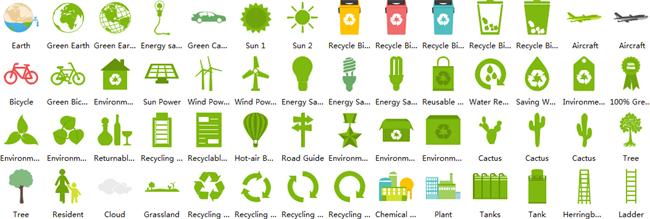Specify some key components in this picture. There are two types of renewable energy sources that are commonly known, which are solar energy and wind energy. How many symbols for recycling are shown? Four. There are a total of three globes present. There are three types of cacti exhibited. The color of the cycles shown in the video is either red and green or red and black. 